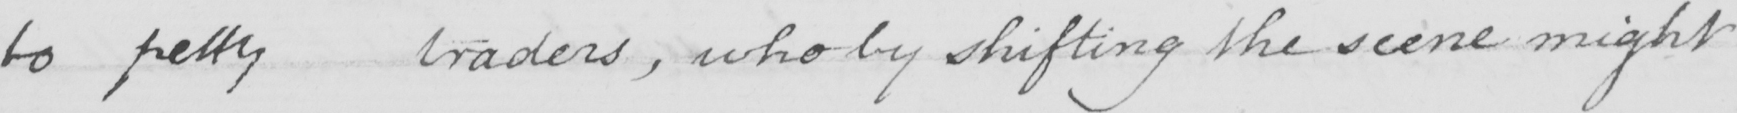Can you tell me what this handwritten text says? to petty traders , who by shifting the scene might 